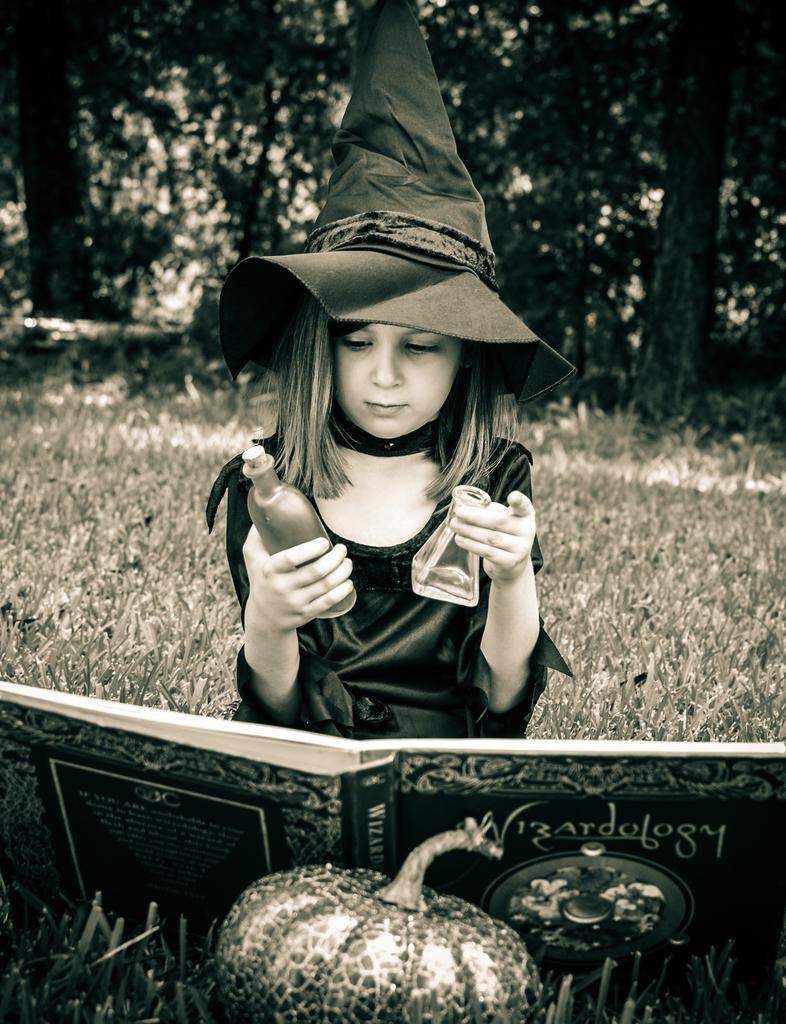Please provide a concise description of this image. This is black and white picture where we can see a girl. She is wearing black color hat and holding bottles in her hand. In front of her book and pumpkin is present. The land is grassy. Background of the image trees are present. 